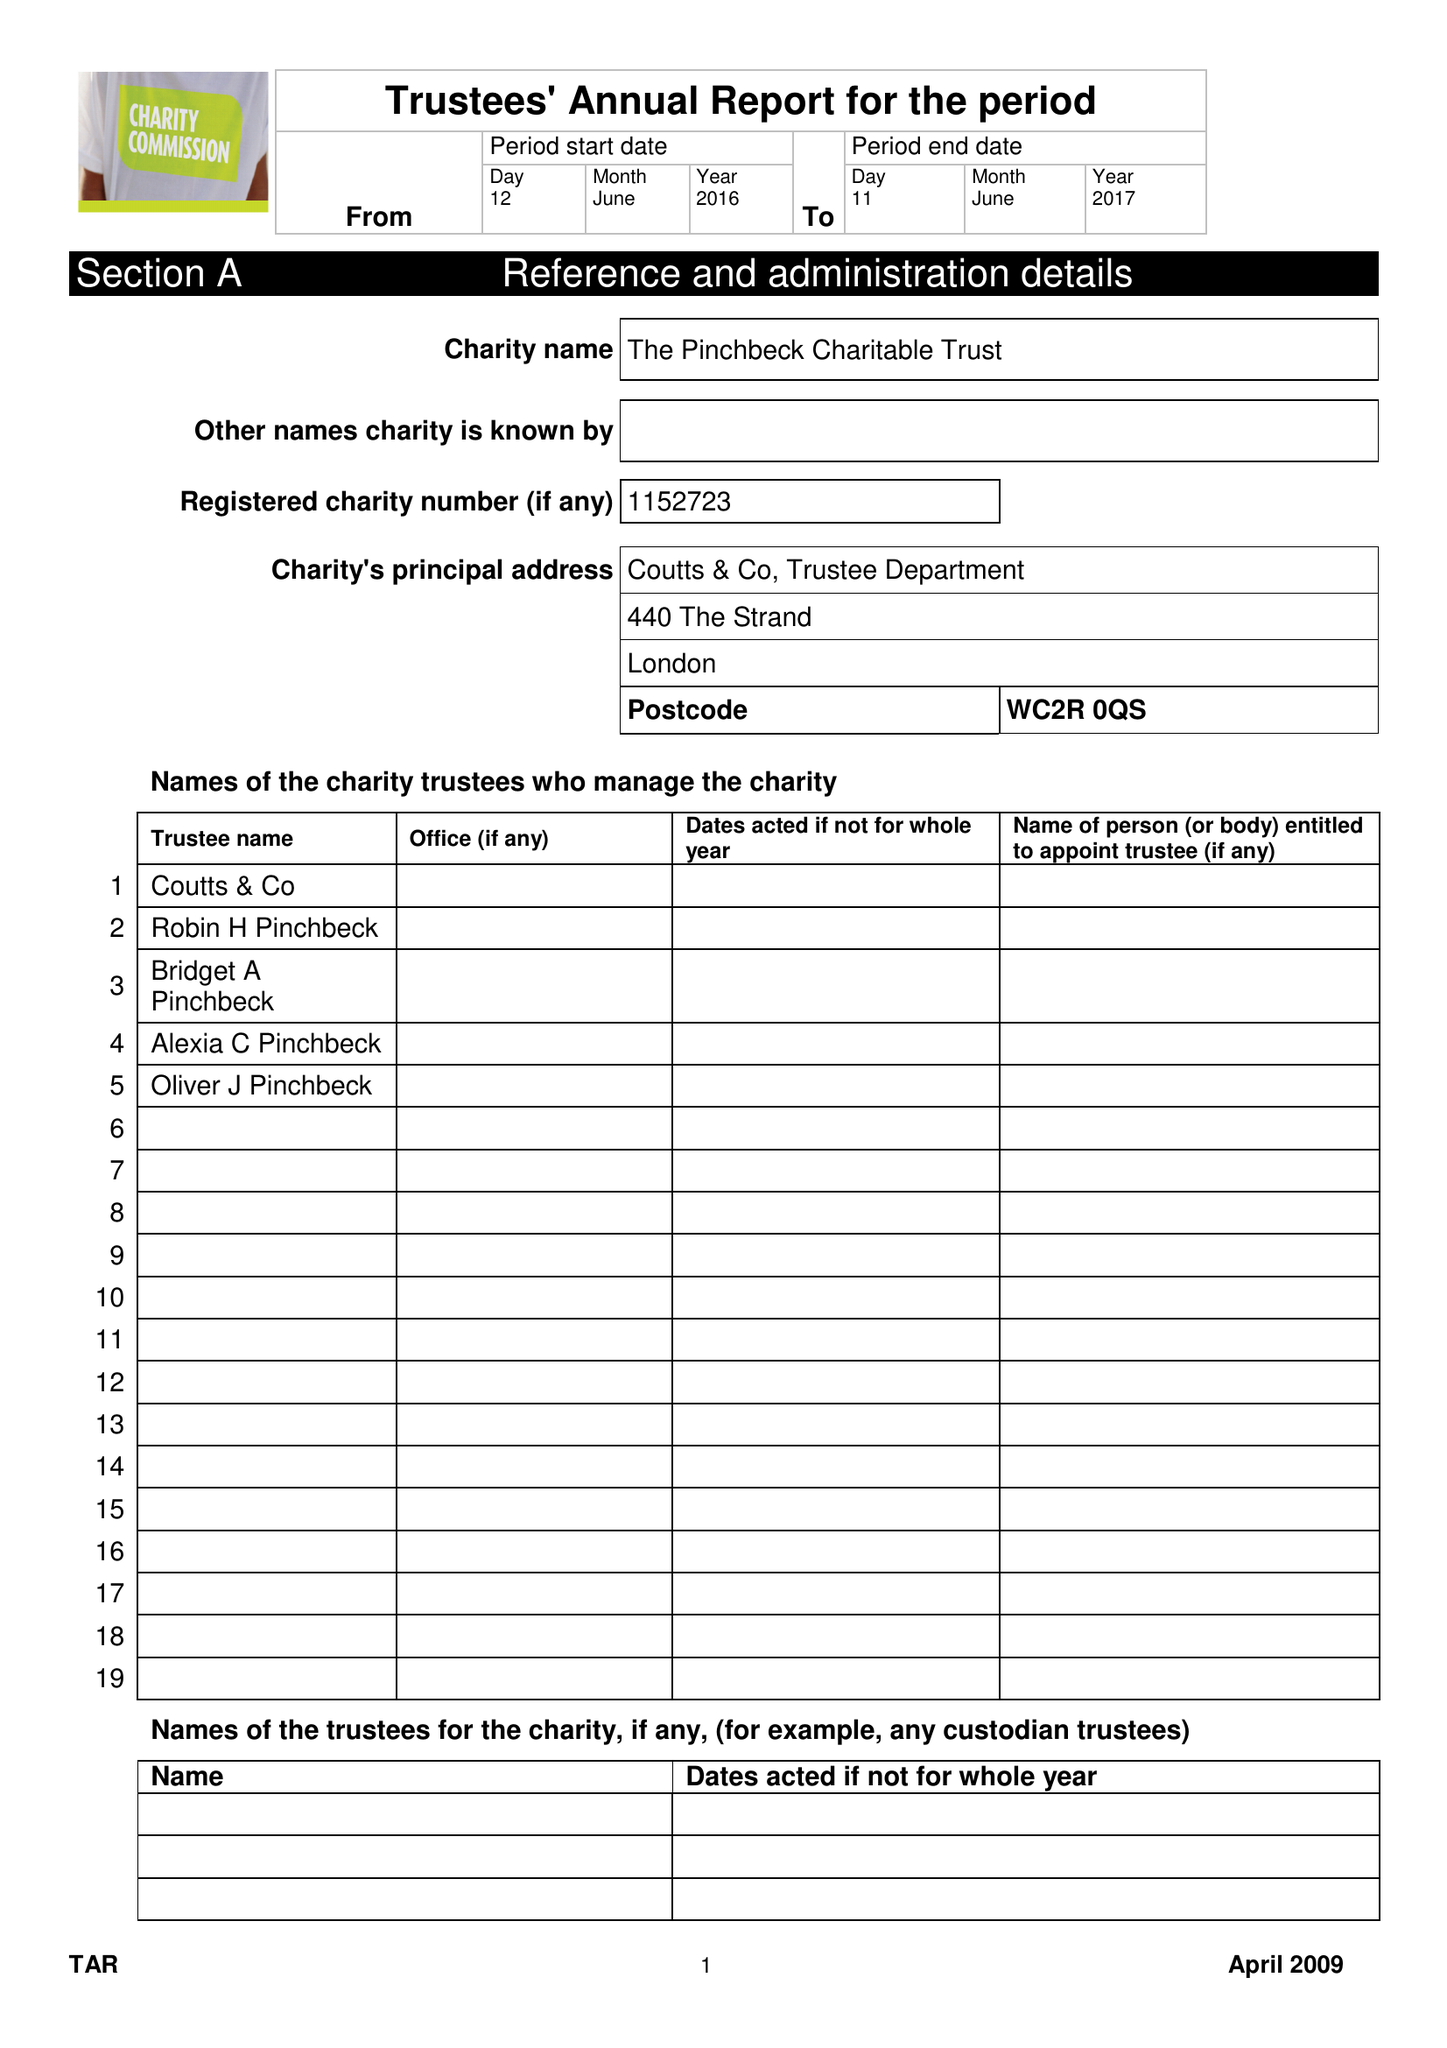What is the value for the charity_number?
Answer the question using a single word or phrase. 1152723 